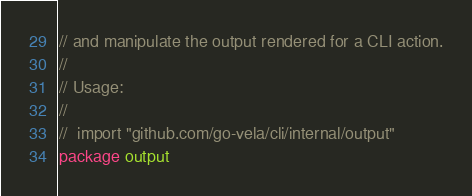Convert code to text. <code><loc_0><loc_0><loc_500><loc_500><_Go_>// and manipulate the output rendered for a CLI action.
//
// Usage:
//
// 	import "github.com/go-vela/cli/internal/output"
package output
</code> 